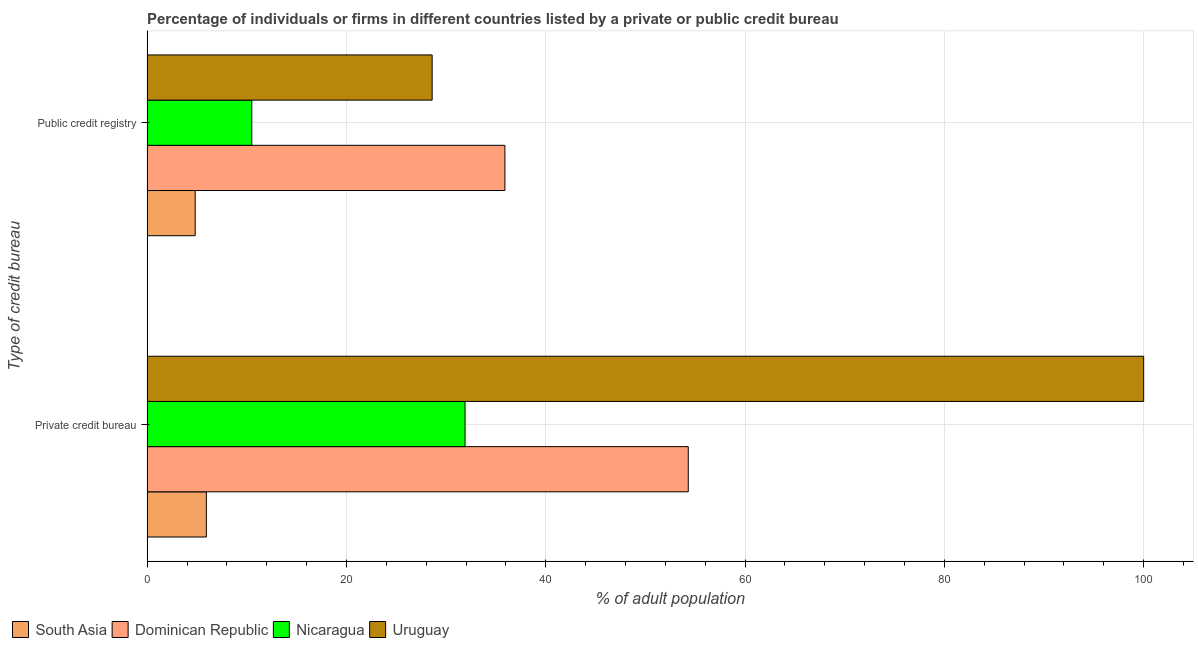How many groups of bars are there?
Provide a short and direct response. 2. How many bars are there on the 1st tick from the top?
Provide a succinct answer. 4. How many bars are there on the 1st tick from the bottom?
Offer a very short reply. 4. What is the label of the 1st group of bars from the top?
Provide a short and direct response. Public credit registry. Across all countries, what is the maximum percentage of firms listed by public credit bureau?
Provide a short and direct response. 35.9. Across all countries, what is the minimum percentage of firms listed by private credit bureau?
Offer a terse response. 5.94. In which country was the percentage of firms listed by public credit bureau maximum?
Your answer should be compact. Dominican Republic. In which country was the percentage of firms listed by private credit bureau minimum?
Offer a terse response. South Asia. What is the total percentage of firms listed by private credit bureau in the graph?
Offer a terse response. 192.14. What is the difference between the percentage of firms listed by public credit bureau in Dominican Republic and that in Uruguay?
Keep it short and to the point. 7.3. What is the difference between the percentage of firms listed by public credit bureau in Dominican Republic and the percentage of firms listed by private credit bureau in South Asia?
Give a very brief answer. 29.96. What is the average percentage of firms listed by public credit bureau per country?
Your answer should be very brief. 19.95. What is the difference between the percentage of firms listed by public credit bureau and percentage of firms listed by private credit bureau in South Asia?
Provide a short and direct response. -1.12. What is the ratio of the percentage of firms listed by private credit bureau in Uruguay to that in Dominican Republic?
Make the answer very short. 1.84. What does the 1st bar from the top in Public credit registry represents?
Provide a succinct answer. Uruguay. What does the 4th bar from the bottom in Private credit bureau represents?
Offer a very short reply. Uruguay. How many countries are there in the graph?
Offer a terse response. 4. Are the values on the major ticks of X-axis written in scientific E-notation?
Offer a terse response. No. Does the graph contain any zero values?
Your answer should be very brief. No. Where does the legend appear in the graph?
Provide a succinct answer. Bottom left. How many legend labels are there?
Provide a short and direct response. 4. What is the title of the graph?
Give a very brief answer. Percentage of individuals or firms in different countries listed by a private or public credit bureau. Does "Ecuador" appear as one of the legend labels in the graph?
Provide a short and direct response. No. What is the label or title of the X-axis?
Your response must be concise. % of adult population. What is the label or title of the Y-axis?
Ensure brevity in your answer.  Type of credit bureau. What is the % of adult population in South Asia in Private credit bureau?
Provide a short and direct response. 5.94. What is the % of adult population of Dominican Republic in Private credit bureau?
Your response must be concise. 54.3. What is the % of adult population in Nicaragua in Private credit bureau?
Offer a very short reply. 31.9. What is the % of adult population in South Asia in Public credit registry?
Your response must be concise. 4.82. What is the % of adult population in Dominican Republic in Public credit registry?
Ensure brevity in your answer.  35.9. What is the % of adult population of Nicaragua in Public credit registry?
Your answer should be compact. 10.5. What is the % of adult population in Uruguay in Public credit registry?
Offer a very short reply. 28.6. Across all Type of credit bureau, what is the maximum % of adult population in South Asia?
Your answer should be very brief. 5.94. Across all Type of credit bureau, what is the maximum % of adult population in Dominican Republic?
Give a very brief answer. 54.3. Across all Type of credit bureau, what is the maximum % of adult population in Nicaragua?
Your answer should be compact. 31.9. Across all Type of credit bureau, what is the maximum % of adult population of Uruguay?
Offer a terse response. 100. Across all Type of credit bureau, what is the minimum % of adult population of South Asia?
Make the answer very short. 4.82. Across all Type of credit bureau, what is the minimum % of adult population in Dominican Republic?
Provide a short and direct response. 35.9. Across all Type of credit bureau, what is the minimum % of adult population of Uruguay?
Provide a short and direct response. 28.6. What is the total % of adult population of South Asia in the graph?
Offer a very short reply. 10.76. What is the total % of adult population of Dominican Republic in the graph?
Make the answer very short. 90.2. What is the total % of adult population of Nicaragua in the graph?
Make the answer very short. 42.4. What is the total % of adult population of Uruguay in the graph?
Make the answer very short. 128.6. What is the difference between the % of adult population of South Asia in Private credit bureau and that in Public credit registry?
Provide a short and direct response. 1.12. What is the difference between the % of adult population in Dominican Republic in Private credit bureau and that in Public credit registry?
Ensure brevity in your answer.  18.4. What is the difference between the % of adult population of Nicaragua in Private credit bureau and that in Public credit registry?
Provide a short and direct response. 21.4. What is the difference between the % of adult population in Uruguay in Private credit bureau and that in Public credit registry?
Your answer should be very brief. 71.4. What is the difference between the % of adult population in South Asia in Private credit bureau and the % of adult population in Dominican Republic in Public credit registry?
Offer a terse response. -29.96. What is the difference between the % of adult population in South Asia in Private credit bureau and the % of adult population in Nicaragua in Public credit registry?
Offer a terse response. -4.56. What is the difference between the % of adult population in South Asia in Private credit bureau and the % of adult population in Uruguay in Public credit registry?
Offer a very short reply. -22.66. What is the difference between the % of adult population of Dominican Republic in Private credit bureau and the % of adult population of Nicaragua in Public credit registry?
Give a very brief answer. 43.8. What is the difference between the % of adult population of Dominican Republic in Private credit bureau and the % of adult population of Uruguay in Public credit registry?
Provide a succinct answer. 25.7. What is the average % of adult population of South Asia per Type of credit bureau?
Make the answer very short. 5.38. What is the average % of adult population of Dominican Republic per Type of credit bureau?
Offer a terse response. 45.1. What is the average % of adult population in Nicaragua per Type of credit bureau?
Offer a very short reply. 21.2. What is the average % of adult population in Uruguay per Type of credit bureau?
Provide a short and direct response. 64.3. What is the difference between the % of adult population of South Asia and % of adult population of Dominican Republic in Private credit bureau?
Offer a very short reply. -48.36. What is the difference between the % of adult population of South Asia and % of adult population of Nicaragua in Private credit bureau?
Give a very brief answer. -25.96. What is the difference between the % of adult population in South Asia and % of adult population in Uruguay in Private credit bureau?
Provide a short and direct response. -94.06. What is the difference between the % of adult population in Dominican Republic and % of adult population in Nicaragua in Private credit bureau?
Provide a short and direct response. 22.4. What is the difference between the % of adult population in Dominican Republic and % of adult population in Uruguay in Private credit bureau?
Your answer should be very brief. -45.7. What is the difference between the % of adult population in Nicaragua and % of adult population in Uruguay in Private credit bureau?
Offer a very short reply. -68.1. What is the difference between the % of adult population of South Asia and % of adult population of Dominican Republic in Public credit registry?
Give a very brief answer. -31.08. What is the difference between the % of adult population of South Asia and % of adult population of Nicaragua in Public credit registry?
Your answer should be compact. -5.68. What is the difference between the % of adult population of South Asia and % of adult population of Uruguay in Public credit registry?
Your answer should be very brief. -23.78. What is the difference between the % of adult population of Dominican Republic and % of adult population of Nicaragua in Public credit registry?
Keep it short and to the point. 25.4. What is the difference between the % of adult population of Nicaragua and % of adult population of Uruguay in Public credit registry?
Offer a very short reply. -18.1. What is the ratio of the % of adult population in South Asia in Private credit bureau to that in Public credit registry?
Your answer should be very brief. 1.23. What is the ratio of the % of adult population of Dominican Republic in Private credit bureau to that in Public credit registry?
Offer a very short reply. 1.51. What is the ratio of the % of adult population of Nicaragua in Private credit bureau to that in Public credit registry?
Your answer should be compact. 3.04. What is the ratio of the % of adult population of Uruguay in Private credit bureau to that in Public credit registry?
Your response must be concise. 3.5. What is the difference between the highest and the second highest % of adult population of South Asia?
Offer a very short reply. 1.12. What is the difference between the highest and the second highest % of adult population of Nicaragua?
Your response must be concise. 21.4. What is the difference between the highest and the second highest % of adult population in Uruguay?
Provide a short and direct response. 71.4. What is the difference between the highest and the lowest % of adult population in South Asia?
Ensure brevity in your answer.  1.12. What is the difference between the highest and the lowest % of adult population of Dominican Republic?
Make the answer very short. 18.4. What is the difference between the highest and the lowest % of adult population in Nicaragua?
Your answer should be very brief. 21.4. What is the difference between the highest and the lowest % of adult population in Uruguay?
Offer a terse response. 71.4. 